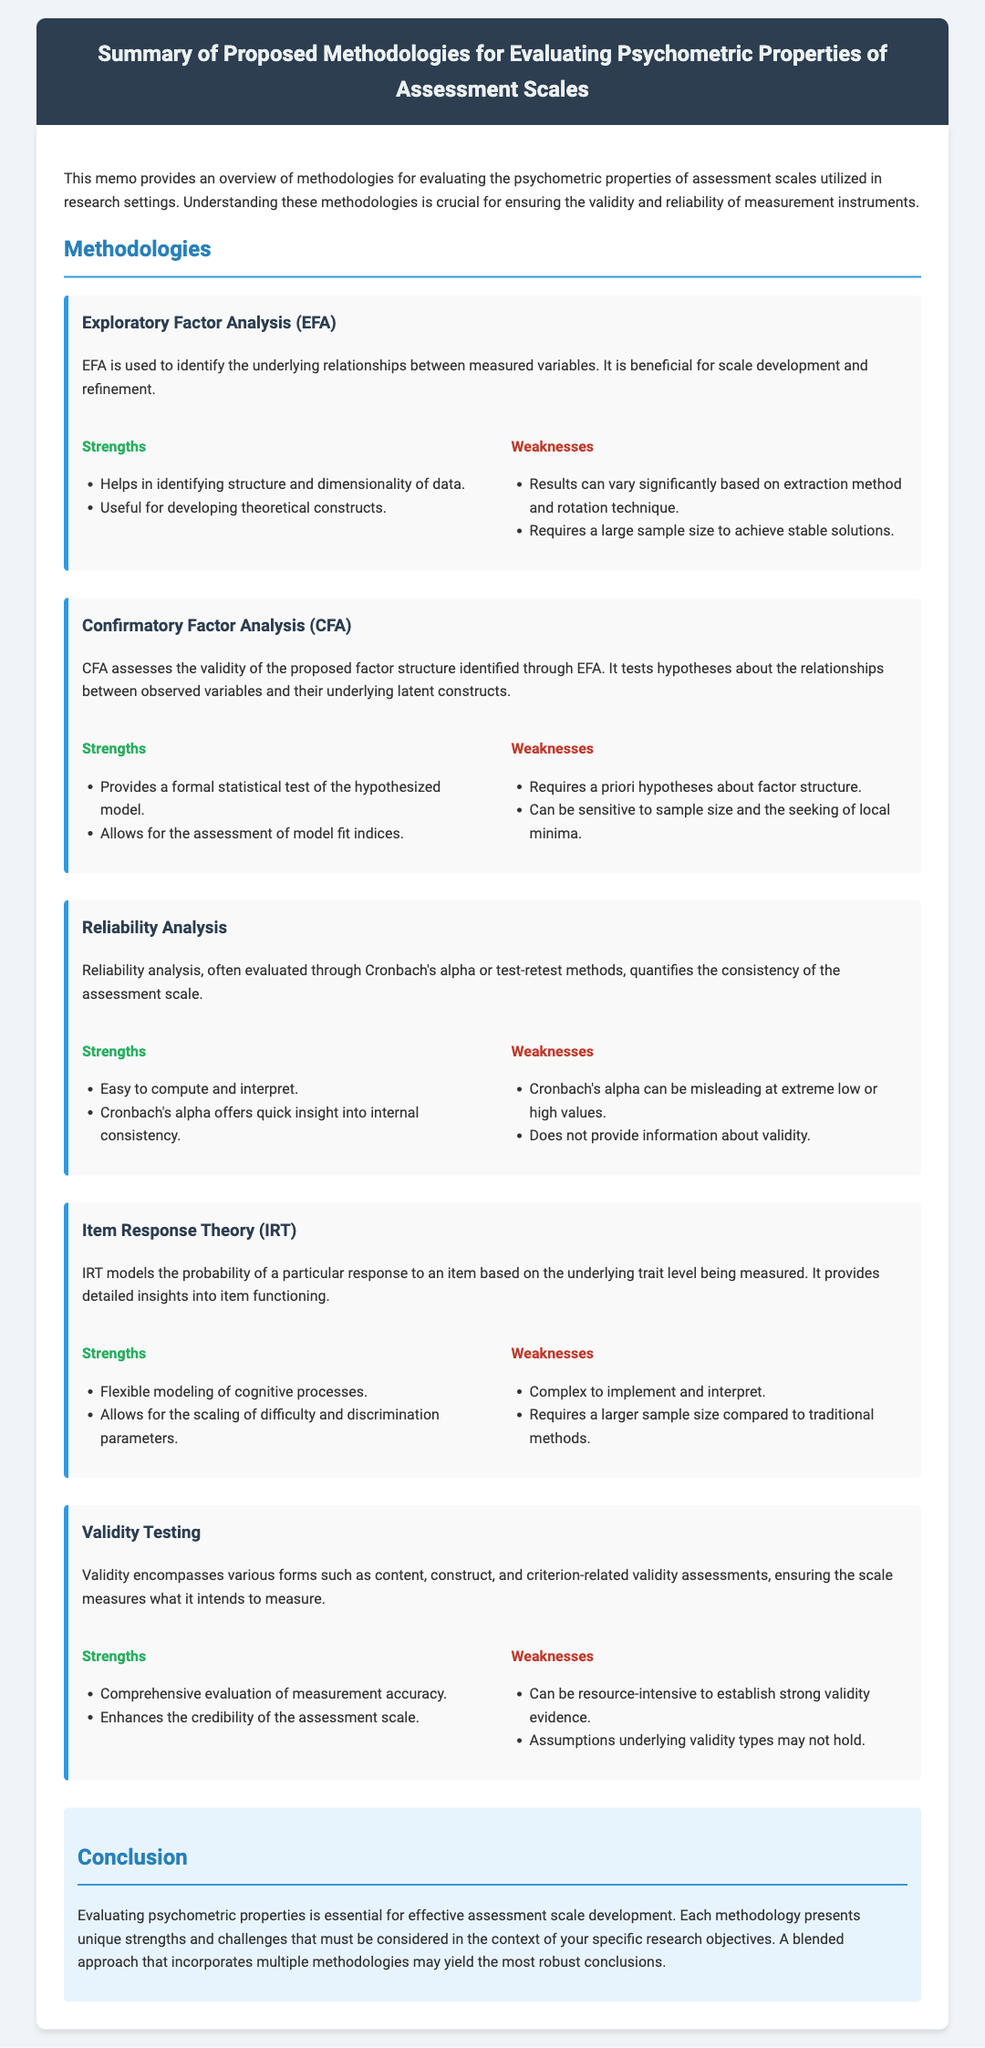What is the title of the memo? The title of the memo is stated at the top of the document, summarizing its purpose for evaluating psychometric properties.
Answer: Summary of Proposed Methodologies for Evaluating Psychometric Properties of Assessment Scales What is one strength of Exploratory Factor Analysis? The strength is mentioned directly under the 'Strengths' section for Exploratory Factor Analysis, indicating its usefulness.
Answer: Helps in identifying structure and dimensionality of data What are the two main types of validation mentioned in the document? The types of validation are specified in the section discussing validity testing, highlighting what should be assessed.
Answer: Content and construct validity How many methodologies are discussed in the memo? The total number of methodologies is listed at the beginning of each methodology section, corresponding to the categories provided.
Answer: Five Which methodology is considered complex to implement and interpret? The specific wording is found in the weaknesses section of one methodology, indicating its complexity.
Answer: Item Response Theory What is a potential weakness of reliability analysis? The weakness is explained under the 'Weaknesses' section of reliability analysis, emphasizing a specific limitation.
Answer: Cronbach's alpha can be misleading at extreme low or high values What conclusion is drawn regarding methodology approaches? The conclusion summarizes the findings of the entire memo, explaining the benefits of combining methodologies.
Answer: A blended approach that incorporates multiple methodologies may yield the most robust conclusions 